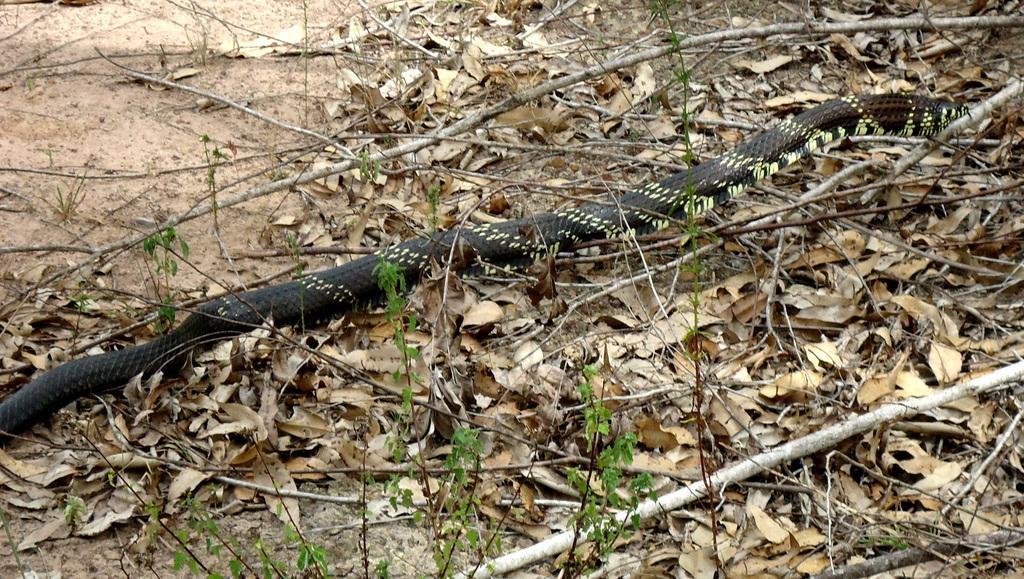How would you summarize this image in a sentence or two? In this image I can see the black color snake. I can see few small plants, few sticks and few dry leaves on the ground. 